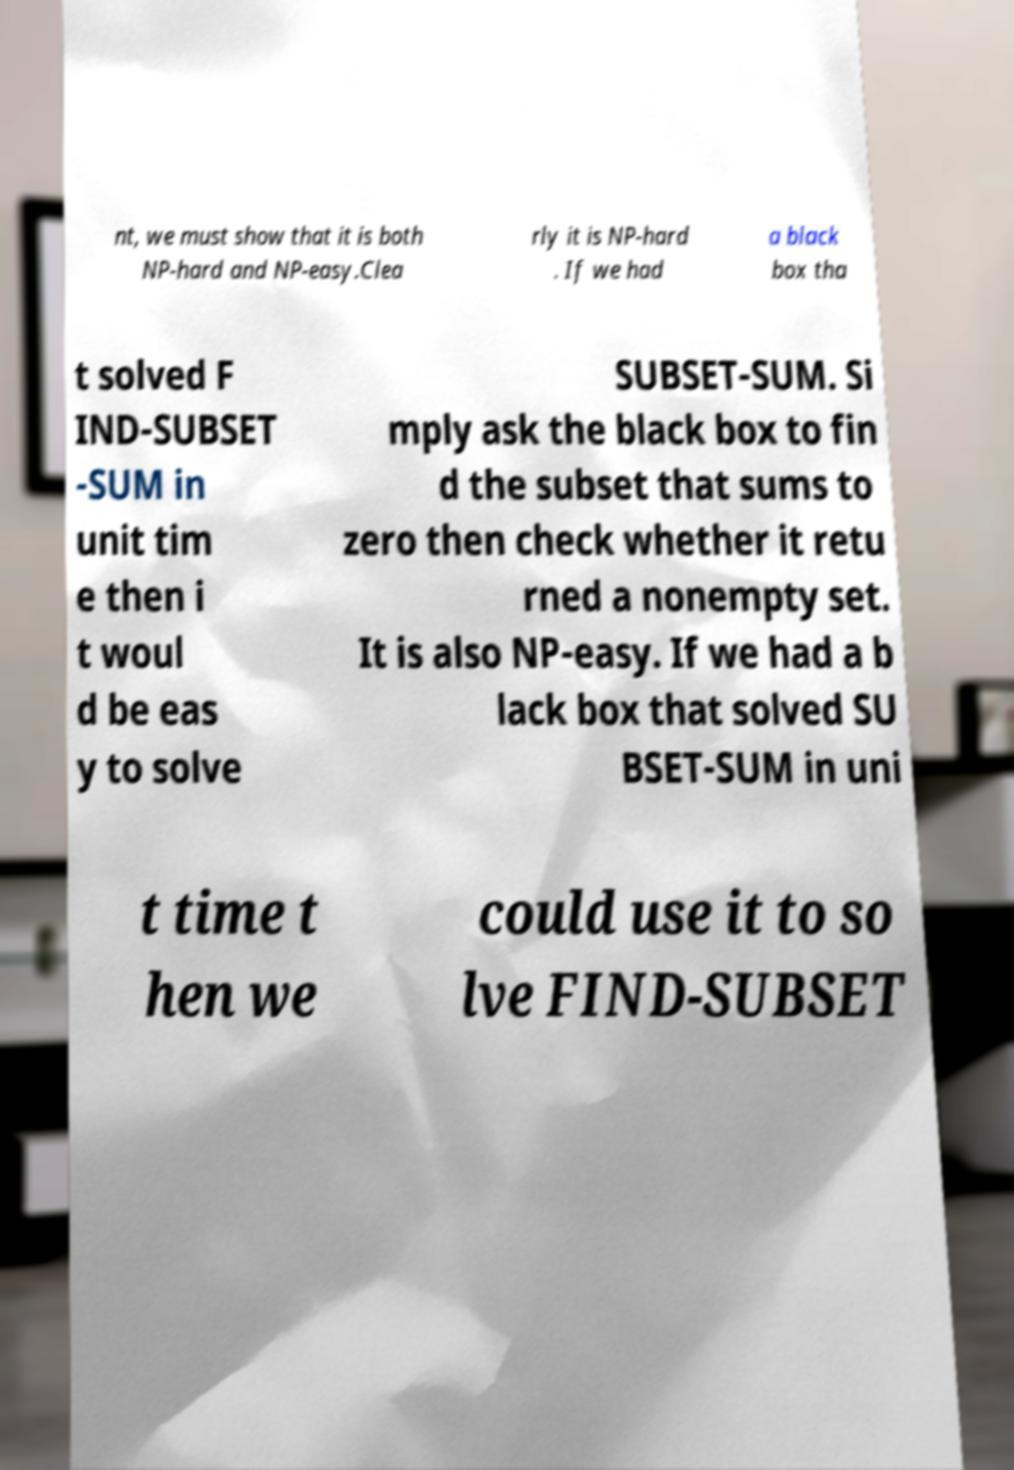Could you extract and type out the text from this image? nt, we must show that it is both NP-hard and NP-easy.Clea rly it is NP-hard . If we had a black box tha t solved F IND-SUBSET -SUM in unit tim e then i t woul d be eas y to solve SUBSET-SUM. Si mply ask the black box to fin d the subset that sums to zero then check whether it retu rned a nonempty set. It is also NP-easy. If we had a b lack box that solved SU BSET-SUM in uni t time t hen we could use it to so lve FIND-SUBSET 